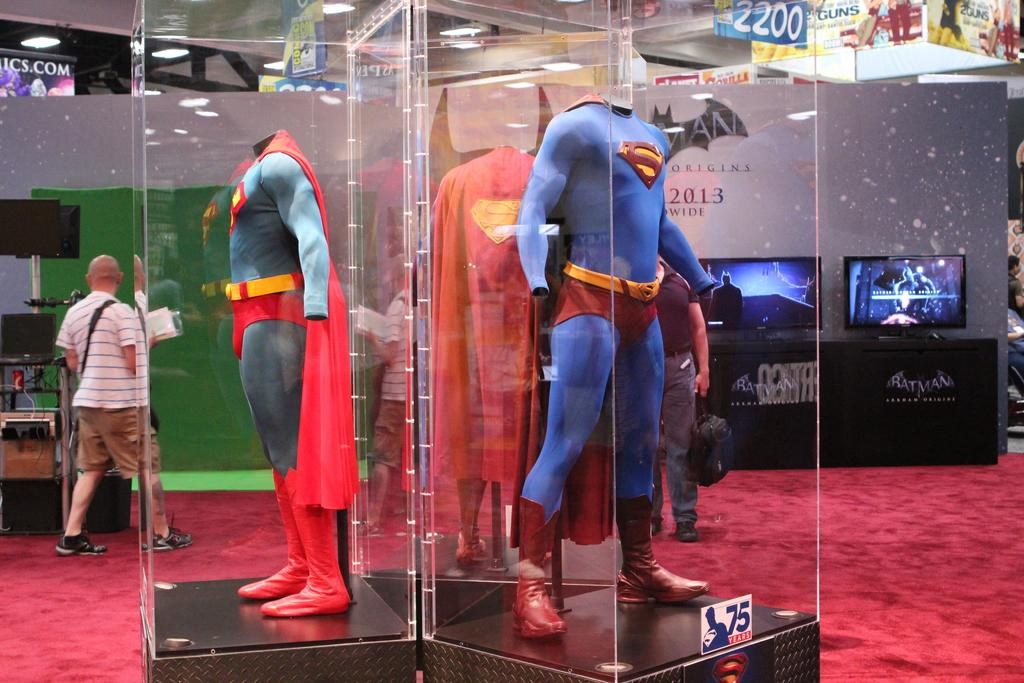<image>
Offer a succinct explanation of the picture presented. A superman costume can be seen on display near a sign that says Origins 2013 